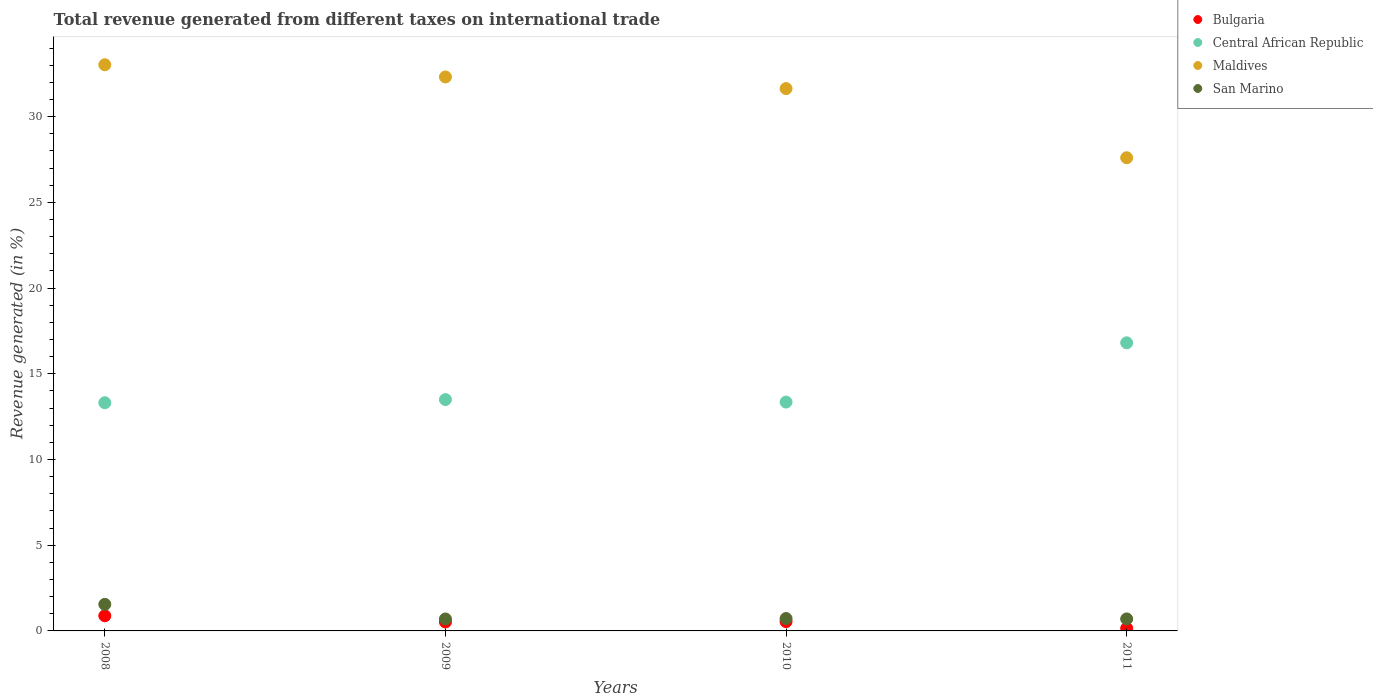How many different coloured dotlines are there?
Provide a short and direct response. 4. What is the total revenue generated in Central African Republic in 2009?
Your answer should be very brief. 13.5. Across all years, what is the maximum total revenue generated in Central African Republic?
Provide a succinct answer. 16.81. Across all years, what is the minimum total revenue generated in Bulgaria?
Offer a terse response. 0.15. In which year was the total revenue generated in Bulgaria maximum?
Your response must be concise. 2008. What is the total total revenue generated in Maldives in the graph?
Provide a succinct answer. 124.59. What is the difference between the total revenue generated in Bulgaria in 2008 and that in 2011?
Offer a very short reply. 0.73. What is the difference between the total revenue generated in Maldives in 2011 and the total revenue generated in Central African Republic in 2010?
Make the answer very short. 14.25. What is the average total revenue generated in Maldives per year?
Your answer should be very brief. 31.15. In the year 2010, what is the difference between the total revenue generated in San Marino and total revenue generated in Bulgaria?
Offer a terse response. 0.18. What is the ratio of the total revenue generated in Bulgaria in 2009 to that in 2011?
Make the answer very short. 3.44. Is the difference between the total revenue generated in San Marino in 2009 and 2011 greater than the difference between the total revenue generated in Bulgaria in 2009 and 2011?
Ensure brevity in your answer.  No. What is the difference between the highest and the second highest total revenue generated in Bulgaria?
Offer a very short reply. 0.34. What is the difference between the highest and the lowest total revenue generated in Central African Republic?
Provide a succinct answer. 3.5. In how many years, is the total revenue generated in San Marino greater than the average total revenue generated in San Marino taken over all years?
Your answer should be very brief. 1. Is the sum of the total revenue generated in Bulgaria in 2010 and 2011 greater than the maximum total revenue generated in San Marino across all years?
Ensure brevity in your answer.  No. Does the total revenue generated in Maldives monotonically increase over the years?
Offer a terse response. No. How many years are there in the graph?
Provide a short and direct response. 4. Does the graph contain any zero values?
Ensure brevity in your answer.  No. Does the graph contain grids?
Offer a terse response. No. Where does the legend appear in the graph?
Provide a short and direct response. Top right. What is the title of the graph?
Offer a terse response. Total revenue generated from different taxes on international trade. What is the label or title of the X-axis?
Keep it short and to the point. Years. What is the label or title of the Y-axis?
Give a very brief answer. Revenue generated (in %). What is the Revenue generated (in %) of Bulgaria in 2008?
Offer a terse response. 0.88. What is the Revenue generated (in %) of Central African Republic in 2008?
Your answer should be very brief. 13.31. What is the Revenue generated (in %) of Maldives in 2008?
Ensure brevity in your answer.  33.03. What is the Revenue generated (in %) of San Marino in 2008?
Provide a succinct answer. 1.55. What is the Revenue generated (in %) of Bulgaria in 2009?
Your answer should be compact. 0.52. What is the Revenue generated (in %) of Central African Republic in 2009?
Ensure brevity in your answer.  13.5. What is the Revenue generated (in %) in Maldives in 2009?
Provide a succinct answer. 32.32. What is the Revenue generated (in %) in San Marino in 2009?
Provide a succinct answer. 0.7. What is the Revenue generated (in %) in Bulgaria in 2010?
Offer a terse response. 0.54. What is the Revenue generated (in %) of Central African Republic in 2010?
Provide a succinct answer. 13.35. What is the Revenue generated (in %) of Maldives in 2010?
Offer a terse response. 31.64. What is the Revenue generated (in %) of San Marino in 2010?
Make the answer very short. 0.72. What is the Revenue generated (in %) of Bulgaria in 2011?
Keep it short and to the point. 0.15. What is the Revenue generated (in %) in Central African Republic in 2011?
Your response must be concise. 16.81. What is the Revenue generated (in %) of Maldives in 2011?
Your answer should be compact. 27.6. What is the Revenue generated (in %) of San Marino in 2011?
Provide a short and direct response. 0.7. Across all years, what is the maximum Revenue generated (in %) of Bulgaria?
Your answer should be compact. 0.88. Across all years, what is the maximum Revenue generated (in %) in Central African Republic?
Provide a succinct answer. 16.81. Across all years, what is the maximum Revenue generated (in %) in Maldives?
Your answer should be compact. 33.03. Across all years, what is the maximum Revenue generated (in %) in San Marino?
Your answer should be very brief. 1.55. Across all years, what is the minimum Revenue generated (in %) in Bulgaria?
Keep it short and to the point. 0.15. Across all years, what is the minimum Revenue generated (in %) of Central African Republic?
Your answer should be very brief. 13.31. Across all years, what is the minimum Revenue generated (in %) in Maldives?
Your answer should be compact. 27.6. Across all years, what is the minimum Revenue generated (in %) of San Marino?
Offer a terse response. 0.7. What is the total Revenue generated (in %) of Bulgaria in the graph?
Your answer should be compact. 2.1. What is the total Revenue generated (in %) in Central African Republic in the graph?
Offer a very short reply. 56.97. What is the total Revenue generated (in %) of Maldives in the graph?
Make the answer very short. 124.59. What is the total Revenue generated (in %) in San Marino in the graph?
Your answer should be very brief. 3.67. What is the difference between the Revenue generated (in %) of Bulgaria in 2008 and that in 2009?
Keep it short and to the point. 0.36. What is the difference between the Revenue generated (in %) in Central African Republic in 2008 and that in 2009?
Make the answer very short. -0.18. What is the difference between the Revenue generated (in %) in Maldives in 2008 and that in 2009?
Offer a very short reply. 0.71. What is the difference between the Revenue generated (in %) in San Marino in 2008 and that in 2009?
Offer a terse response. 0.85. What is the difference between the Revenue generated (in %) of Bulgaria in 2008 and that in 2010?
Your answer should be compact. 0.34. What is the difference between the Revenue generated (in %) in Central African Republic in 2008 and that in 2010?
Make the answer very short. -0.04. What is the difference between the Revenue generated (in %) in Maldives in 2008 and that in 2010?
Your response must be concise. 1.39. What is the difference between the Revenue generated (in %) of San Marino in 2008 and that in 2010?
Offer a terse response. 0.83. What is the difference between the Revenue generated (in %) in Bulgaria in 2008 and that in 2011?
Ensure brevity in your answer.  0.73. What is the difference between the Revenue generated (in %) of Central African Republic in 2008 and that in 2011?
Offer a very short reply. -3.5. What is the difference between the Revenue generated (in %) of Maldives in 2008 and that in 2011?
Make the answer very short. 5.42. What is the difference between the Revenue generated (in %) in San Marino in 2008 and that in 2011?
Offer a terse response. 0.85. What is the difference between the Revenue generated (in %) of Bulgaria in 2009 and that in 2010?
Make the answer very short. -0.02. What is the difference between the Revenue generated (in %) in Central African Republic in 2009 and that in 2010?
Give a very brief answer. 0.14. What is the difference between the Revenue generated (in %) of Maldives in 2009 and that in 2010?
Your answer should be very brief. 0.68. What is the difference between the Revenue generated (in %) in San Marino in 2009 and that in 2010?
Ensure brevity in your answer.  -0.03. What is the difference between the Revenue generated (in %) in Bulgaria in 2009 and that in 2011?
Offer a terse response. 0.37. What is the difference between the Revenue generated (in %) of Central African Republic in 2009 and that in 2011?
Your answer should be very brief. -3.31. What is the difference between the Revenue generated (in %) of Maldives in 2009 and that in 2011?
Ensure brevity in your answer.  4.71. What is the difference between the Revenue generated (in %) of San Marino in 2009 and that in 2011?
Make the answer very short. -0. What is the difference between the Revenue generated (in %) in Bulgaria in 2010 and that in 2011?
Offer a terse response. 0.39. What is the difference between the Revenue generated (in %) in Central African Republic in 2010 and that in 2011?
Your answer should be very brief. -3.46. What is the difference between the Revenue generated (in %) in Maldives in 2010 and that in 2011?
Provide a succinct answer. 4.04. What is the difference between the Revenue generated (in %) in San Marino in 2010 and that in 2011?
Keep it short and to the point. 0.02. What is the difference between the Revenue generated (in %) of Bulgaria in 2008 and the Revenue generated (in %) of Central African Republic in 2009?
Keep it short and to the point. -12.61. What is the difference between the Revenue generated (in %) of Bulgaria in 2008 and the Revenue generated (in %) of Maldives in 2009?
Provide a succinct answer. -31.43. What is the difference between the Revenue generated (in %) of Bulgaria in 2008 and the Revenue generated (in %) of San Marino in 2009?
Your answer should be compact. 0.19. What is the difference between the Revenue generated (in %) in Central African Republic in 2008 and the Revenue generated (in %) in Maldives in 2009?
Give a very brief answer. -19.01. What is the difference between the Revenue generated (in %) in Central African Republic in 2008 and the Revenue generated (in %) in San Marino in 2009?
Make the answer very short. 12.62. What is the difference between the Revenue generated (in %) in Maldives in 2008 and the Revenue generated (in %) in San Marino in 2009?
Make the answer very short. 32.33. What is the difference between the Revenue generated (in %) in Bulgaria in 2008 and the Revenue generated (in %) in Central African Republic in 2010?
Offer a very short reply. -12.47. What is the difference between the Revenue generated (in %) in Bulgaria in 2008 and the Revenue generated (in %) in Maldives in 2010?
Provide a short and direct response. -30.76. What is the difference between the Revenue generated (in %) of Bulgaria in 2008 and the Revenue generated (in %) of San Marino in 2010?
Make the answer very short. 0.16. What is the difference between the Revenue generated (in %) in Central African Republic in 2008 and the Revenue generated (in %) in Maldives in 2010?
Give a very brief answer. -18.33. What is the difference between the Revenue generated (in %) of Central African Republic in 2008 and the Revenue generated (in %) of San Marino in 2010?
Provide a succinct answer. 12.59. What is the difference between the Revenue generated (in %) of Maldives in 2008 and the Revenue generated (in %) of San Marino in 2010?
Give a very brief answer. 32.31. What is the difference between the Revenue generated (in %) in Bulgaria in 2008 and the Revenue generated (in %) in Central African Republic in 2011?
Your answer should be very brief. -15.92. What is the difference between the Revenue generated (in %) in Bulgaria in 2008 and the Revenue generated (in %) in Maldives in 2011?
Provide a succinct answer. -26.72. What is the difference between the Revenue generated (in %) of Bulgaria in 2008 and the Revenue generated (in %) of San Marino in 2011?
Offer a terse response. 0.18. What is the difference between the Revenue generated (in %) in Central African Republic in 2008 and the Revenue generated (in %) in Maldives in 2011?
Your response must be concise. -14.29. What is the difference between the Revenue generated (in %) of Central African Republic in 2008 and the Revenue generated (in %) of San Marino in 2011?
Your response must be concise. 12.61. What is the difference between the Revenue generated (in %) in Maldives in 2008 and the Revenue generated (in %) in San Marino in 2011?
Your answer should be compact. 32.33. What is the difference between the Revenue generated (in %) in Bulgaria in 2009 and the Revenue generated (in %) in Central African Republic in 2010?
Make the answer very short. -12.83. What is the difference between the Revenue generated (in %) in Bulgaria in 2009 and the Revenue generated (in %) in Maldives in 2010?
Your response must be concise. -31.12. What is the difference between the Revenue generated (in %) of Bulgaria in 2009 and the Revenue generated (in %) of San Marino in 2010?
Make the answer very short. -0.2. What is the difference between the Revenue generated (in %) in Central African Republic in 2009 and the Revenue generated (in %) in Maldives in 2010?
Provide a succinct answer. -18.14. What is the difference between the Revenue generated (in %) in Central African Republic in 2009 and the Revenue generated (in %) in San Marino in 2010?
Offer a very short reply. 12.77. What is the difference between the Revenue generated (in %) of Maldives in 2009 and the Revenue generated (in %) of San Marino in 2010?
Your answer should be very brief. 31.59. What is the difference between the Revenue generated (in %) in Bulgaria in 2009 and the Revenue generated (in %) in Central African Republic in 2011?
Give a very brief answer. -16.28. What is the difference between the Revenue generated (in %) in Bulgaria in 2009 and the Revenue generated (in %) in Maldives in 2011?
Make the answer very short. -27.08. What is the difference between the Revenue generated (in %) in Bulgaria in 2009 and the Revenue generated (in %) in San Marino in 2011?
Ensure brevity in your answer.  -0.18. What is the difference between the Revenue generated (in %) in Central African Republic in 2009 and the Revenue generated (in %) in Maldives in 2011?
Your answer should be compact. -14.11. What is the difference between the Revenue generated (in %) of Central African Republic in 2009 and the Revenue generated (in %) of San Marino in 2011?
Your answer should be compact. 12.8. What is the difference between the Revenue generated (in %) in Maldives in 2009 and the Revenue generated (in %) in San Marino in 2011?
Ensure brevity in your answer.  31.62. What is the difference between the Revenue generated (in %) in Bulgaria in 2010 and the Revenue generated (in %) in Central African Republic in 2011?
Your answer should be very brief. -16.26. What is the difference between the Revenue generated (in %) of Bulgaria in 2010 and the Revenue generated (in %) of Maldives in 2011?
Make the answer very short. -27.06. What is the difference between the Revenue generated (in %) of Bulgaria in 2010 and the Revenue generated (in %) of San Marino in 2011?
Your response must be concise. -0.16. What is the difference between the Revenue generated (in %) of Central African Republic in 2010 and the Revenue generated (in %) of Maldives in 2011?
Your answer should be compact. -14.25. What is the difference between the Revenue generated (in %) in Central African Republic in 2010 and the Revenue generated (in %) in San Marino in 2011?
Your response must be concise. 12.65. What is the difference between the Revenue generated (in %) of Maldives in 2010 and the Revenue generated (in %) of San Marino in 2011?
Offer a very short reply. 30.94. What is the average Revenue generated (in %) of Bulgaria per year?
Your answer should be very brief. 0.53. What is the average Revenue generated (in %) of Central African Republic per year?
Keep it short and to the point. 14.24. What is the average Revenue generated (in %) of Maldives per year?
Offer a very short reply. 31.15. What is the average Revenue generated (in %) in San Marino per year?
Provide a short and direct response. 0.92. In the year 2008, what is the difference between the Revenue generated (in %) of Bulgaria and Revenue generated (in %) of Central African Republic?
Keep it short and to the point. -12.43. In the year 2008, what is the difference between the Revenue generated (in %) in Bulgaria and Revenue generated (in %) in Maldives?
Your answer should be compact. -32.15. In the year 2008, what is the difference between the Revenue generated (in %) in Bulgaria and Revenue generated (in %) in San Marino?
Your answer should be compact. -0.67. In the year 2008, what is the difference between the Revenue generated (in %) of Central African Republic and Revenue generated (in %) of Maldives?
Offer a very short reply. -19.72. In the year 2008, what is the difference between the Revenue generated (in %) of Central African Republic and Revenue generated (in %) of San Marino?
Provide a short and direct response. 11.76. In the year 2008, what is the difference between the Revenue generated (in %) of Maldives and Revenue generated (in %) of San Marino?
Offer a terse response. 31.48. In the year 2009, what is the difference between the Revenue generated (in %) of Bulgaria and Revenue generated (in %) of Central African Republic?
Make the answer very short. -12.97. In the year 2009, what is the difference between the Revenue generated (in %) of Bulgaria and Revenue generated (in %) of Maldives?
Keep it short and to the point. -31.79. In the year 2009, what is the difference between the Revenue generated (in %) in Bulgaria and Revenue generated (in %) in San Marino?
Your response must be concise. -0.17. In the year 2009, what is the difference between the Revenue generated (in %) of Central African Republic and Revenue generated (in %) of Maldives?
Make the answer very short. -18.82. In the year 2009, what is the difference between the Revenue generated (in %) of Central African Republic and Revenue generated (in %) of San Marino?
Your response must be concise. 12.8. In the year 2009, what is the difference between the Revenue generated (in %) in Maldives and Revenue generated (in %) in San Marino?
Your answer should be compact. 31.62. In the year 2010, what is the difference between the Revenue generated (in %) of Bulgaria and Revenue generated (in %) of Central African Republic?
Provide a short and direct response. -12.81. In the year 2010, what is the difference between the Revenue generated (in %) in Bulgaria and Revenue generated (in %) in Maldives?
Ensure brevity in your answer.  -31.1. In the year 2010, what is the difference between the Revenue generated (in %) in Bulgaria and Revenue generated (in %) in San Marino?
Offer a very short reply. -0.18. In the year 2010, what is the difference between the Revenue generated (in %) of Central African Republic and Revenue generated (in %) of Maldives?
Ensure brevity in your answer.  -18.29. In the year 2010, what is the difference between the Revenue generated (in %) in Central African Republic and Revenue generated (in %) in San Marino?
Provide a succinct answer. 12.63. In the year 2010, what is the difference between the Revenue generated (in %) of Maldives and Revenue generated (in %) of San Marino?
Offer a very short reply. 30.92. In the year 2011, what is the difference between the Revenue generated (in %) of Bulgaria and Revenue generated (in %) of Central African Republic?
Give a very brief answer. -16.66. In the year 2011, what is the difference between the Revenue generated (in %) of Bulgaria and Revenue generated (in %) of Maldives?
Keep it short and to the point. -27.45. In the year 2011, what is the difference between the Revenue generated (in %) of Bulgaria and Revenue generated (in %) of San Marino?
Provide a succinct answer. -0.55. In the year 2011, what is the difference between the Revenue generated (in %) of Central African Republic and Revenue generated (in %) of Maldives?
Provide a short and direct response. -10.8. In the year 2011, what is the difference between the Revenue generated (in %) of Central African Republic and Revenue generated (in %) of San Marino?
Provide a short and direct response. 16.11. In the year 2011, what is the difference between the Revenue generated (in %) in Maldives and Revenue generated (in %) in San Marino?
Provide a succinct answer. 26.9. What is the ratio of the Revenue generated (in %) of Bulgaria in 2008 to that in 2009?
Provide a short and direct response. 1.69. What is the ratio of the Revenue generated (in %) of Central African Republic in 2008 to that in 2009?
Offer a terse response. 0.99. What is the ratio of the Revenue generated (in %) of San Marino in 2008 to that in 2009?
Ensure brevity in your answer.  2.23. What is the ratio of the Revenue generated (in %) of Bulgaria in 2008 to that in 2010?
Your response must be concise. 1.62. What is the ratio of the Revenue generated (in %) in Maldives in 2008 to that in 2010?
Ensure brevity in your answer.  1.04. What is the ratio of the Revenue generated (in %) of San Marino in 2008 to that in 2010?
Your answer should be very brief. 2.15. What is the ratio of the Revenue generated (in %) of Bulgaria in 2008 to that in 2011?
Provide a succinct answer. 5.82. What is the ratio of the Revenue generated (in %) of Central African Republic in 2008 to that in 2011?
Ensure brevity in your answer.  0.79. What is the ratio of the Revenue generated (in %) of Maldives in 2008 to that in 2011?
Your answer should be very brief. 1.2. What is the ratio of the Revenue generated (in %) of San Marino in 2008 to that in 2011?
Keep it short and to the point. 2.22. What is the ratio of the Revenue generated (in %) in Bulgaria in 2009 to that in 2010?
Your response must be concise. 0.96. What is the ratio of the Revenue generated (in %) in Central African Republic in 2009 to that in 2010?
Keep it short and to the point. 1.01. What is the ratio of the Revenue generated (in %) in Maldives in 2009 to that in 2010?
Offer a very short reply. 1.02. What is the ratio of the Revenue generated (in %) of San Marino in 2009 to that in 2010?
Provide a succinct answer. 0.96. What is the ratio of the Revenue generated (in %) in Bulgaria in 2009 to that in 2011?
Provide a succinct answer. 3.44. What is the ratio of the Revenue generated (in %) of Central African Republic in 2009 to that in 2011?
Offer a terse response. 0.8. What is the ratio of the Revenue generated (in %) of Maldives in 2009 to that in 2011?
Your answer should be very brief. 1.17. What is the ratio of the Revenue generated (in %) in San Marino in 2009 to that in 2011?
Offer a terse response. 0.99. What is the ratio of the Revenue generated (in %) of Bulgaria in 2010 to that in 2011?
Make the answer very short. 3.58. What is the ratio of the Revenue generated (in %) of Central African Republic in 2010 to that in 2011?
Ensure brevity in your answer.  0.79. What is the ratio of the Revenue generated (in %) of Maldives in 2010 to that in 2011?
Give a very brief answer. 1.15. What is the ratio of the Revenue generated (in %) of San Marino in 2010 to that in 2011?
Give a very brief answer. 1.03. What is the difference between the highest and the second highest Revenue generated (in %) of Bulgaria?
Provide a short and direct response. 0.34. What is the difference between the highest and the second highest Revenue generated (in %) in Central African Republic?
Your response must be concise. 3.31. What is the difference between the highest and the second highest Revenue generated (in %) of Maldives?
Provide a short and direct response. 0.71. What is the difference between the highest and the second highest Revenue generated (in %) of San Marino?
Your answer should be compact. 0.83. What is the difference between the highest and the lowest Revenue generated (in %) of Bulgaria?
Keep it short and to the point. 0.73. What is the difference between the highest and the lowest Revenue generated (in %) in Central African Republic?
Offer a terse response. 3.5. What is the difference between the highest and the lowest Revenue generated (in %) of Maldives?
Your answer should be compact. 5.42. What is the difference between the highest and the lowest Revenue generated (in %) in San Marino?
Make the answer very short. 0.85. 